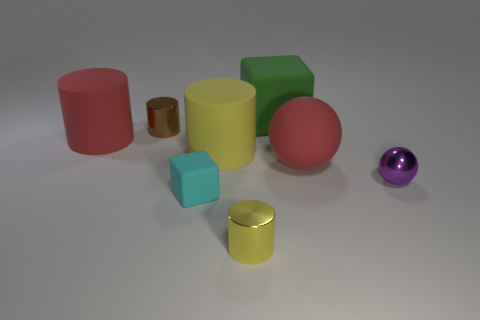Which objects are most reflective? The smaller cylinders appear to be the most reflective objects, noticing their shiny surfaces and the way they catch the light compared to the other objects. 